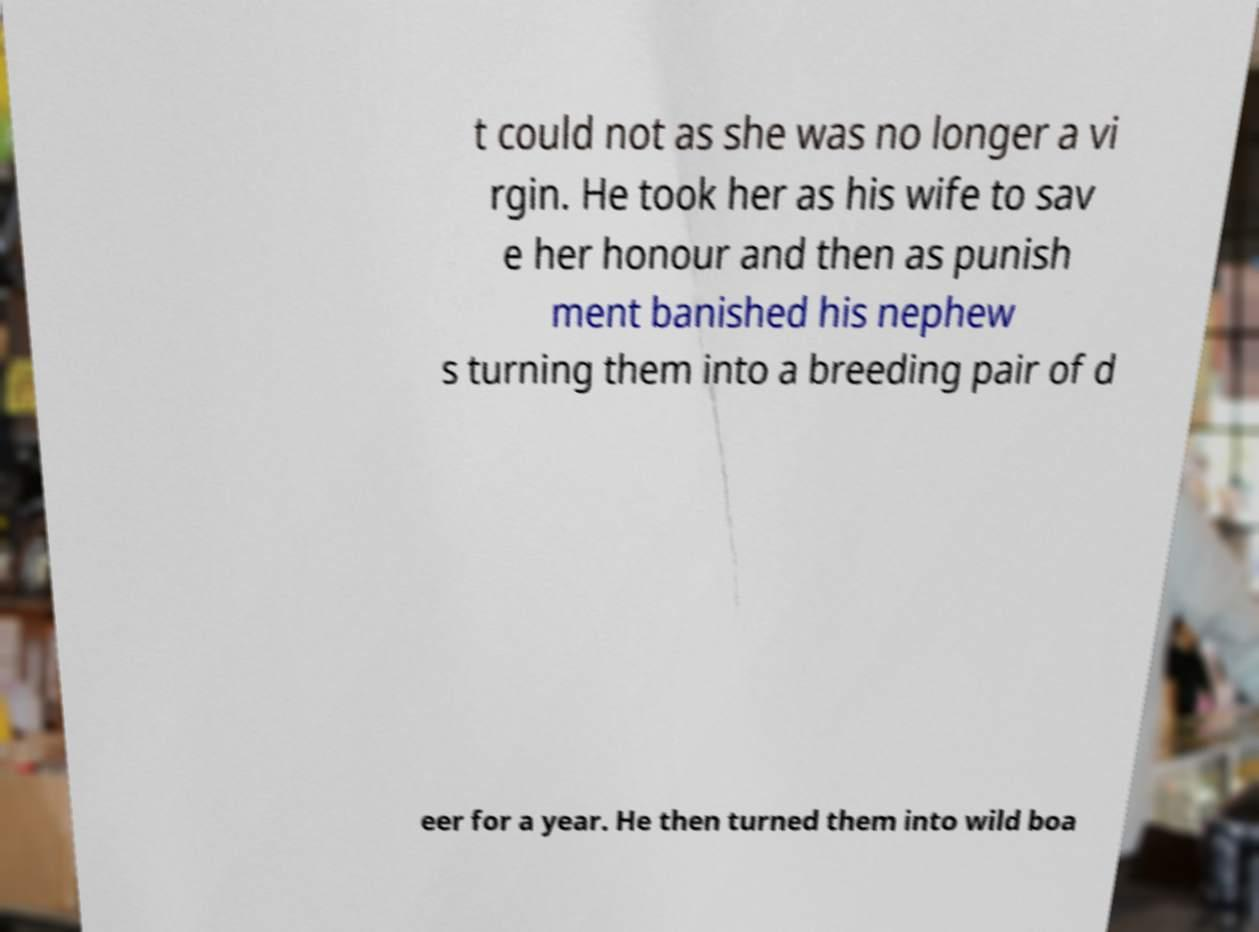Could you assist in decoding the text presented in this image and type it out clearly? t could not as she was no longer a vi rgin. He took her as his wife to sav e her honour and then as punish ment banished his nephew s turning them into a breeding pair of d eer for a year. He then turned them into wild boa 